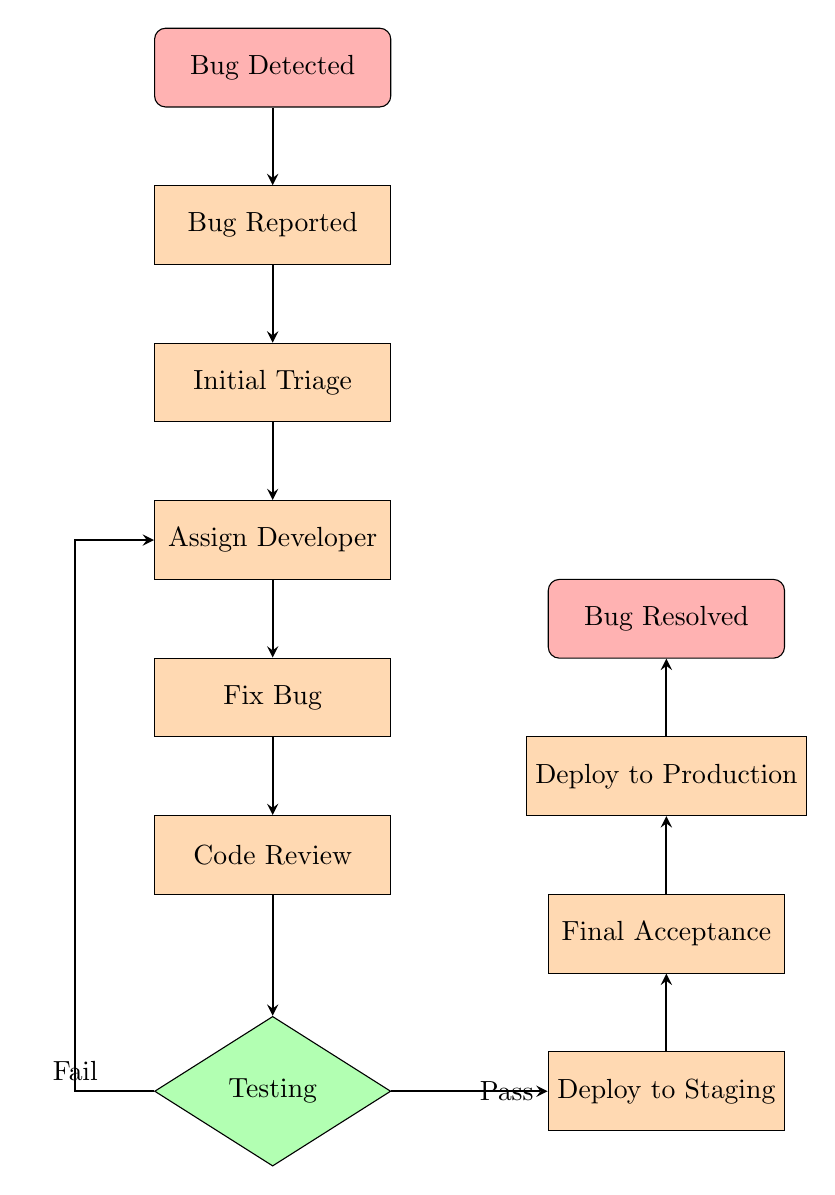What's the first step in the bug reporting workflow? The diagram starts with "Bug Detected" as the initial point of the workflow. This is the first node in the flow chart.
Answer: Bug Detected How many total steps are there in the workflow? The diagram includes nine steps from "Bug Reported" to "Deploy to Production," plus the initial detection and final resolution nodes. Counting all of these gives a total of 11 nodes.
Answer: 11 What happens if testing fails? The diagram indicates that if testing fails, the workflow loops back to the "Assign Developer" step for further investigation and fixing. This is represented by the arrow leading back to that node.
Answer: Assign Developer Who gives final approval for the bug fix? The step labeled "Final Acceptance" in the diagram specifies that the product owner or a designated individual is responsible for giving the final approval.
Answer: Product owner What is the last step in the bug reporting workflow? According to the flow chart, the last node is "Bug Resolved," which marks the completion of the workflow after deploying the fix to production.
Answer: Bug Resolved What step occurs immediately after fixing the bug? The workflow proceeds to "Code Review" immediately after the "Fix Bug" step, making it the next node that follows fixing the bug.
Answer: Code Review Which step involves input from the QA team? The "Testing" step indicates that the QA team tests the bug fix to ensure it is resolved, highlighting their involvement in that stage of the workflow.
Answer: Testing What is done after "Deploy to Staging"? The diagram shows that after "Deploy to Staging," the next step is "Final Acceptance," highlighting that verification follows deployment to the staging environment.
Answer: Final Acceptance 